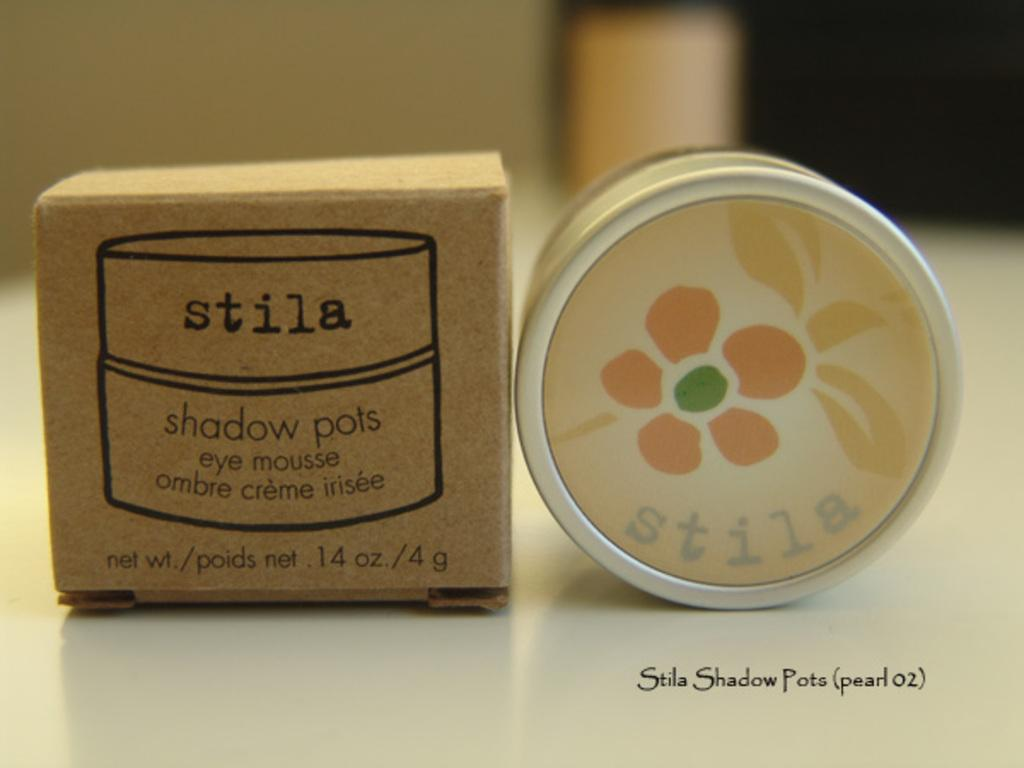<image>
Share a concise interpretation of the image provided. Foundation product for the eyes that is Shadow Pots from the brand Stila. 